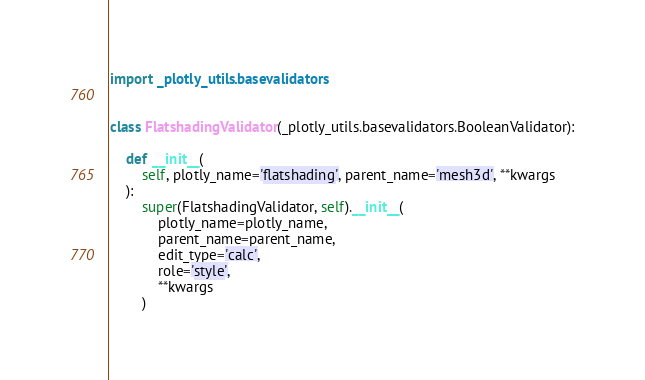<code> <loc_0><loc_0><loc_500><loc_500><_Python_>import _plotly_utils.basevalidators


class FlatshadingValidator(_plotly_utils.basevalidators.BooleanValidator):

    def __init__(
        self, plotly_name='flatshading', parent_name='mesh3d', **kwargs
    ):
        super(FlatshadingValidator, self).__init__(
            plotly_name=plotly_name,
            parent_name=parent_name,
            edit_type='calc',
            role='style',
            **kwargs
        )
</code> 